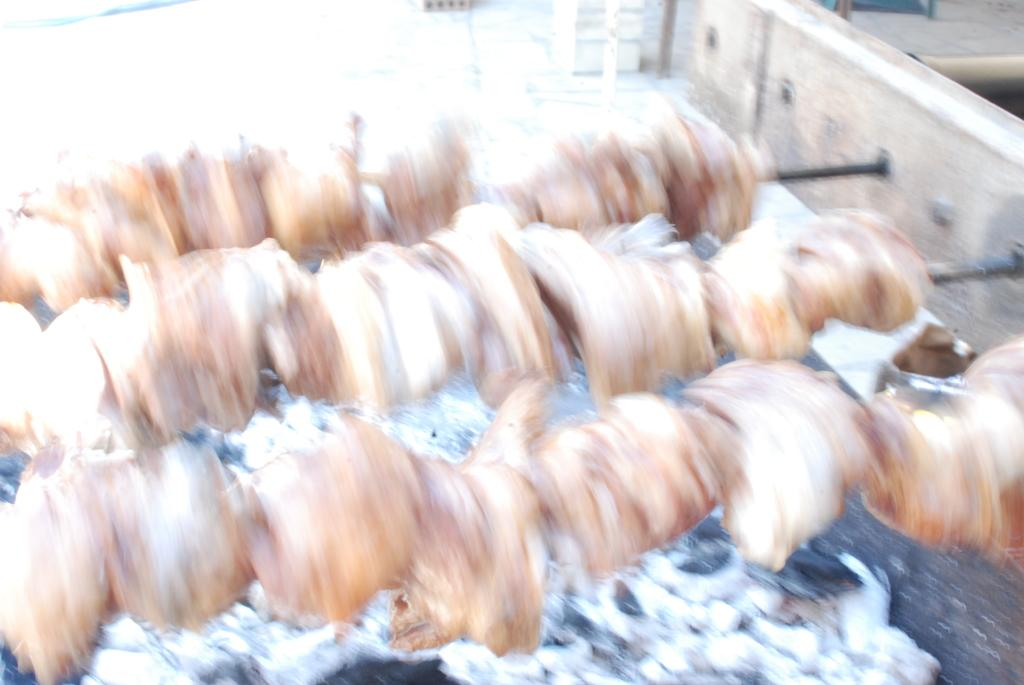What is the main subject of the image? The main subject of the image is barbecues. How are the barbecues positioned in the image? The barbecues are attached to a wooden plank. What color is the object at the bottom of the image? The object at the bottom of the image is white. Can you tell me how many pumpkins are placed on the stocking in the image? There are no pumpkins or stockings present in the image; it features barbecues attached to a wooden plank. 